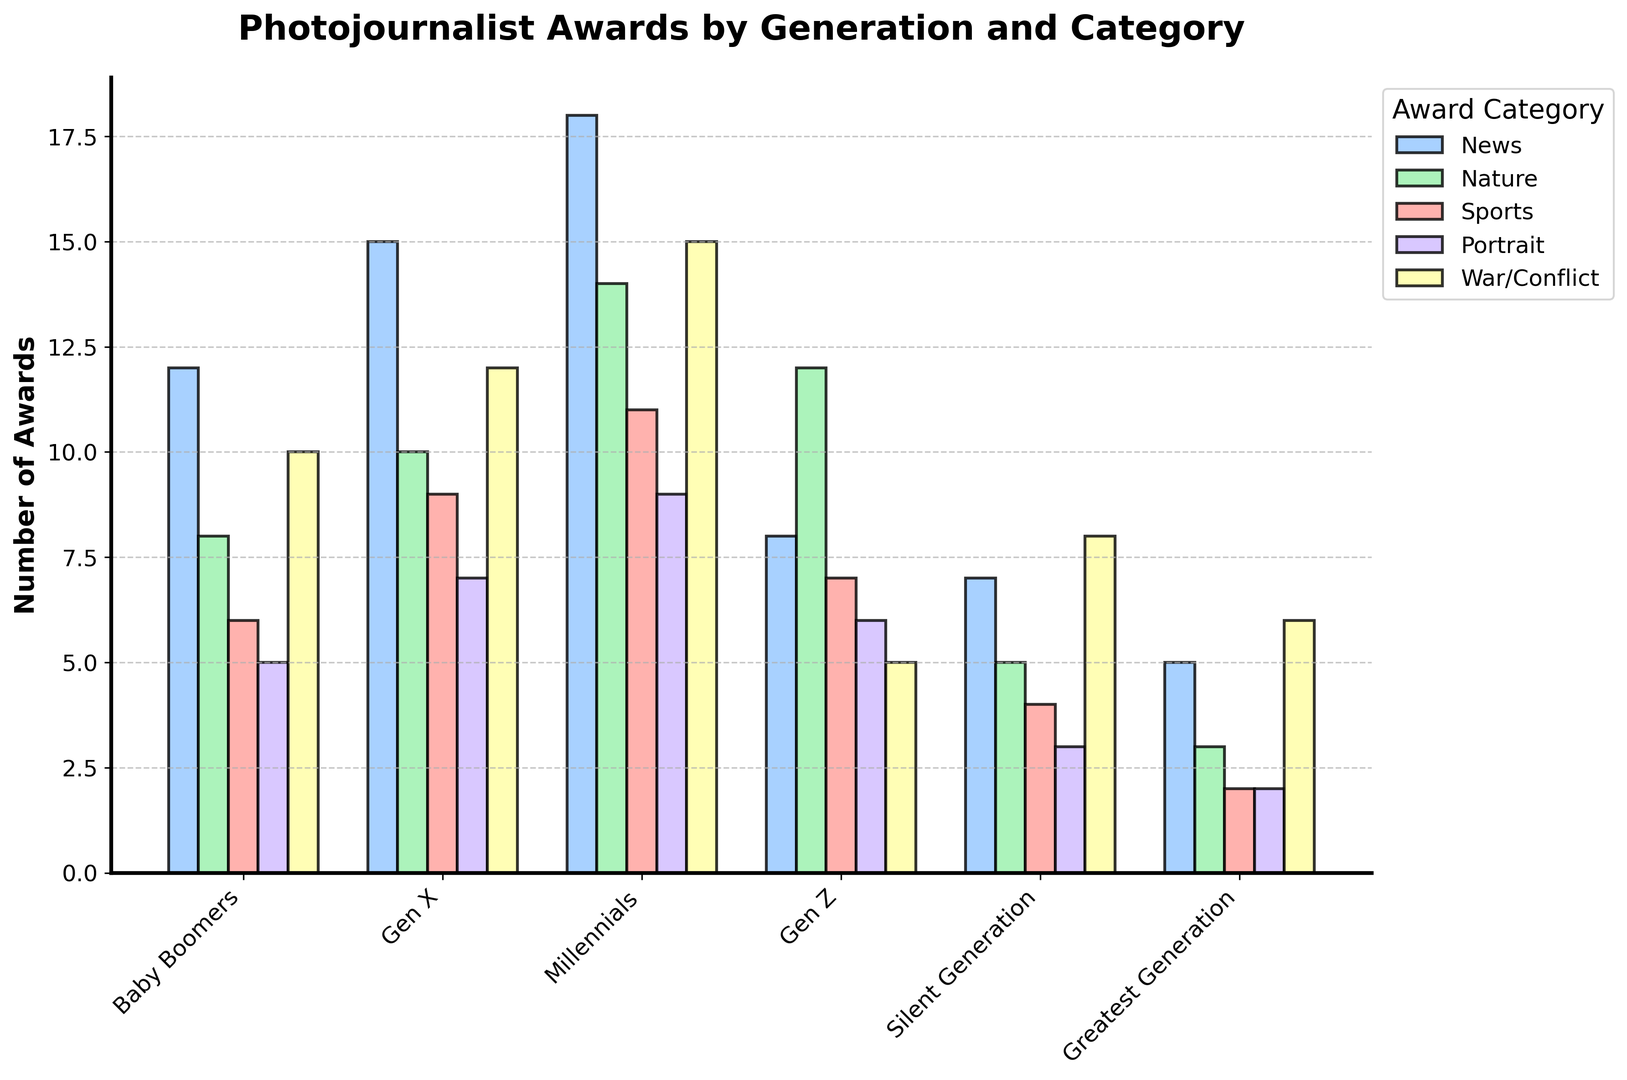Which generation has won the most awards in the "Sports" category? By looking at the height of the bars in the "Sports" category, we see that the Millennials generation has the tallest bar, indicating they have won the most awards.
Answer: Millennials How many total awards were won by the Gen X generation across all categories? Sum the numbers for the Gen X generation: 15 (News) + 10 (Nature) + 9 (Sports) + 7 (Portrait) + 12 (War/Conflict) = 53.
Answer: 53 Which category does the Baby Boomers generation excel in the most? By comparing the heights of all bars for the Baby Boomers, the "News" category has the tallest bar with a value of 12 among all categories.
Answer: News What is the difference in the number of awards won in the "Portrait" category between the Silent Generation and Gen Z? The Silent Generation won 3 awards while Gen Z won 6. The difference is 6 - 3 = 3.
Answer: 3 Which category sees a decreasing trend from Baby Boomers to Greatest Generation? Analyzing the height of the bars from left to right, the categories "News", "Nature", "Sports", and "Portrait" all generally decrease, while "War/Conflict" doesn't follow a decreasing trend.
Answer: News, Nature, Sports, Portrait What is the average number of awards won by the Greatest Generation across all categories? Sum the numbers for the Greatest Generation: 5 (News) + 3 (Nature) + 2 (Sports) + 2 (Portrait) + 6 (War/Conflict) = 18. Dividing by the 5 categories: 18 ÷ 5 = 3.6.
Answer: 3.6 Between Millennials and Gen Z, which generation won more awards in the "Nature" category, and by how much? Millennials won 14 awards while Gen Z won 12 in the "Nature" category. The difference is 14 - 12 = 2.
Answer: Millennials, 2 Which generation has the smallest number of awards in the "War/Conflict" category? By comparing the heights of the bars in the "War/Conflict" category, Gen Z has the smallest bar with a value of 5.
Answer: Gen Z Is there any category where the Gen Z generation outperforms the Silent Generation? By looking at each category, Gen Z outperforms the Silent Generation in the "Nature" and "Sports" categories with 12 and 7 awards, respectively, versus 5 and 4 awards for the Silent Generation.
Answer: Nature, Sports How many more awards did Millennials win in the "Nature" category compared to the Greatest Generation in the "News" category? Millennials won 14 awards in the "Nature" category, and the Greatest Generation won 5 in the "News" category. The difference is 14 - 5 = 9.
Answer: 9 